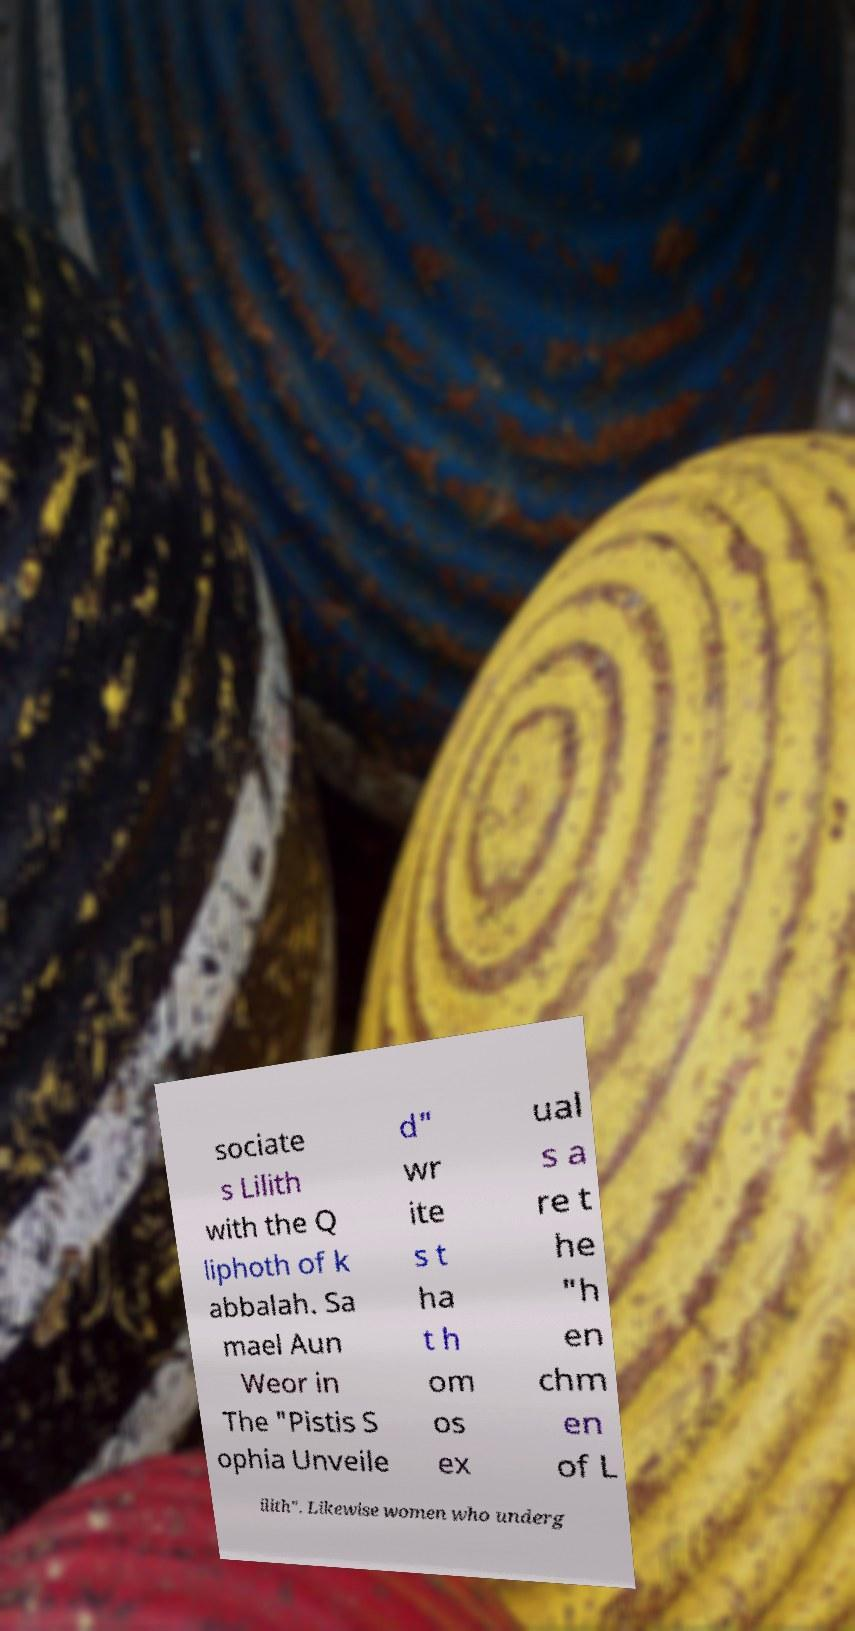I need the written content from this picture converted into text. Can you do that? sociate s Lilith with the Q liphoth of k abbalah. Sa mael Aun Weor in The "Pistis S ophia Unveile d" wr ite s t ha t h om os ex ual s a re t he "h en chm en of L ilith". Likewise women who underg 